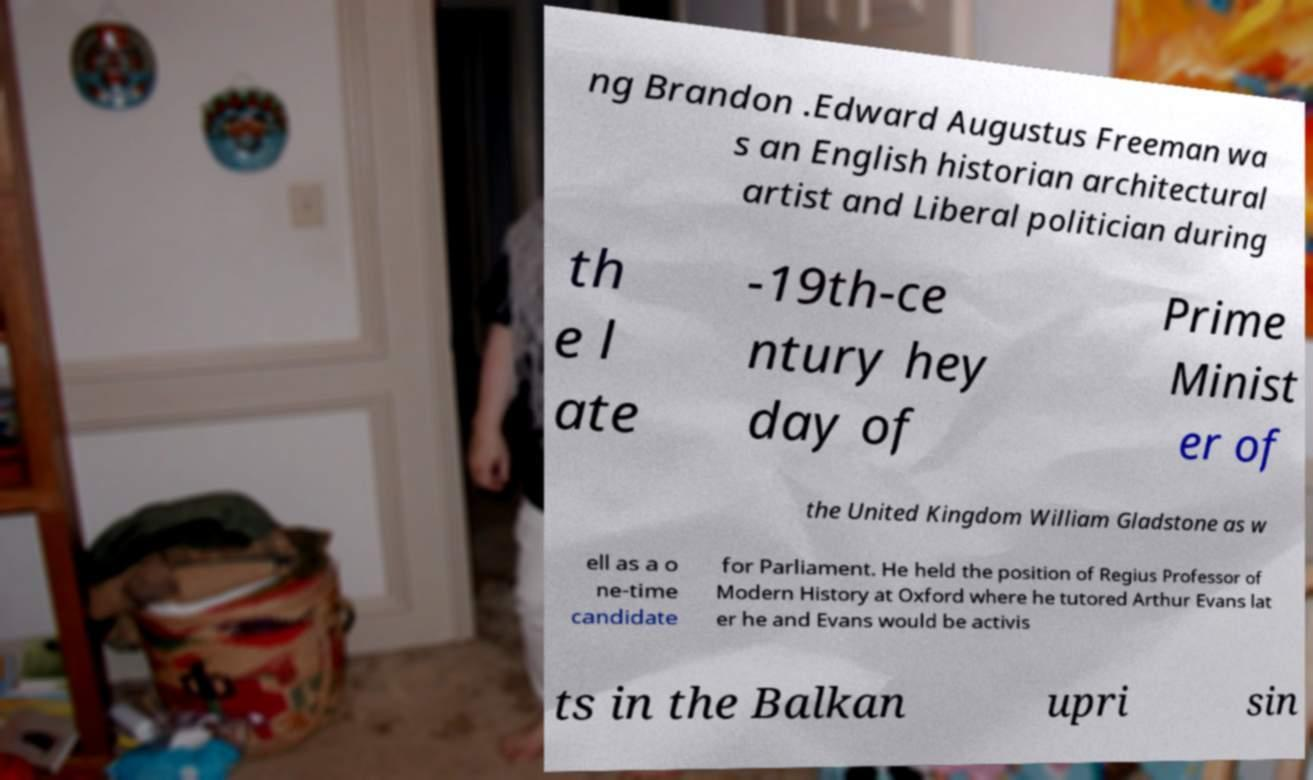There's text embedded in this image that I need extracted. Can you transcribe it verbatim? ng Brandon .Edward Augustus Freeman wa s an English historian architectural artist and Liberal politician during th e l ate -19th-ce ntury hey day of Prime Minist er of the United Kingdom William Gladstone as w ell as a o ne-time candidate for Parliament. He held the position of Regius Professor of Modern History at Oxford where he tutored Arthur Evans lat er he and Evans would be activis ts in the Balkan upri sin 